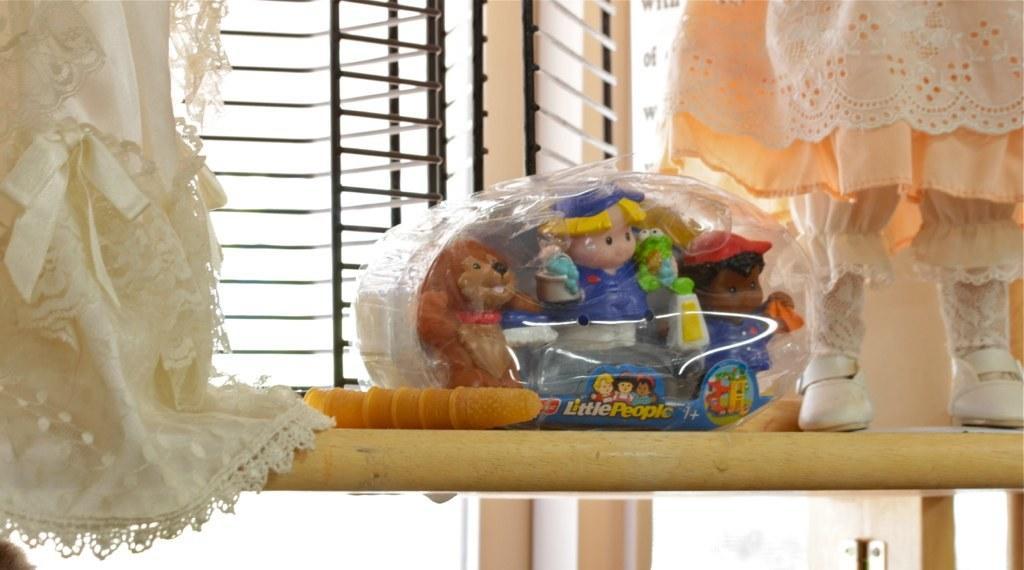In one or two sentences, can you explain what this image depicts? In this image there is a wooden board, and on the board there is a dress and some toys. And in the background there is window grills, and wall and some objects at the bottom. 